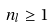<formula> <loc_0><loc_0><loc_500><loc_500>n _ { l } \geq 1 \,</formula> 